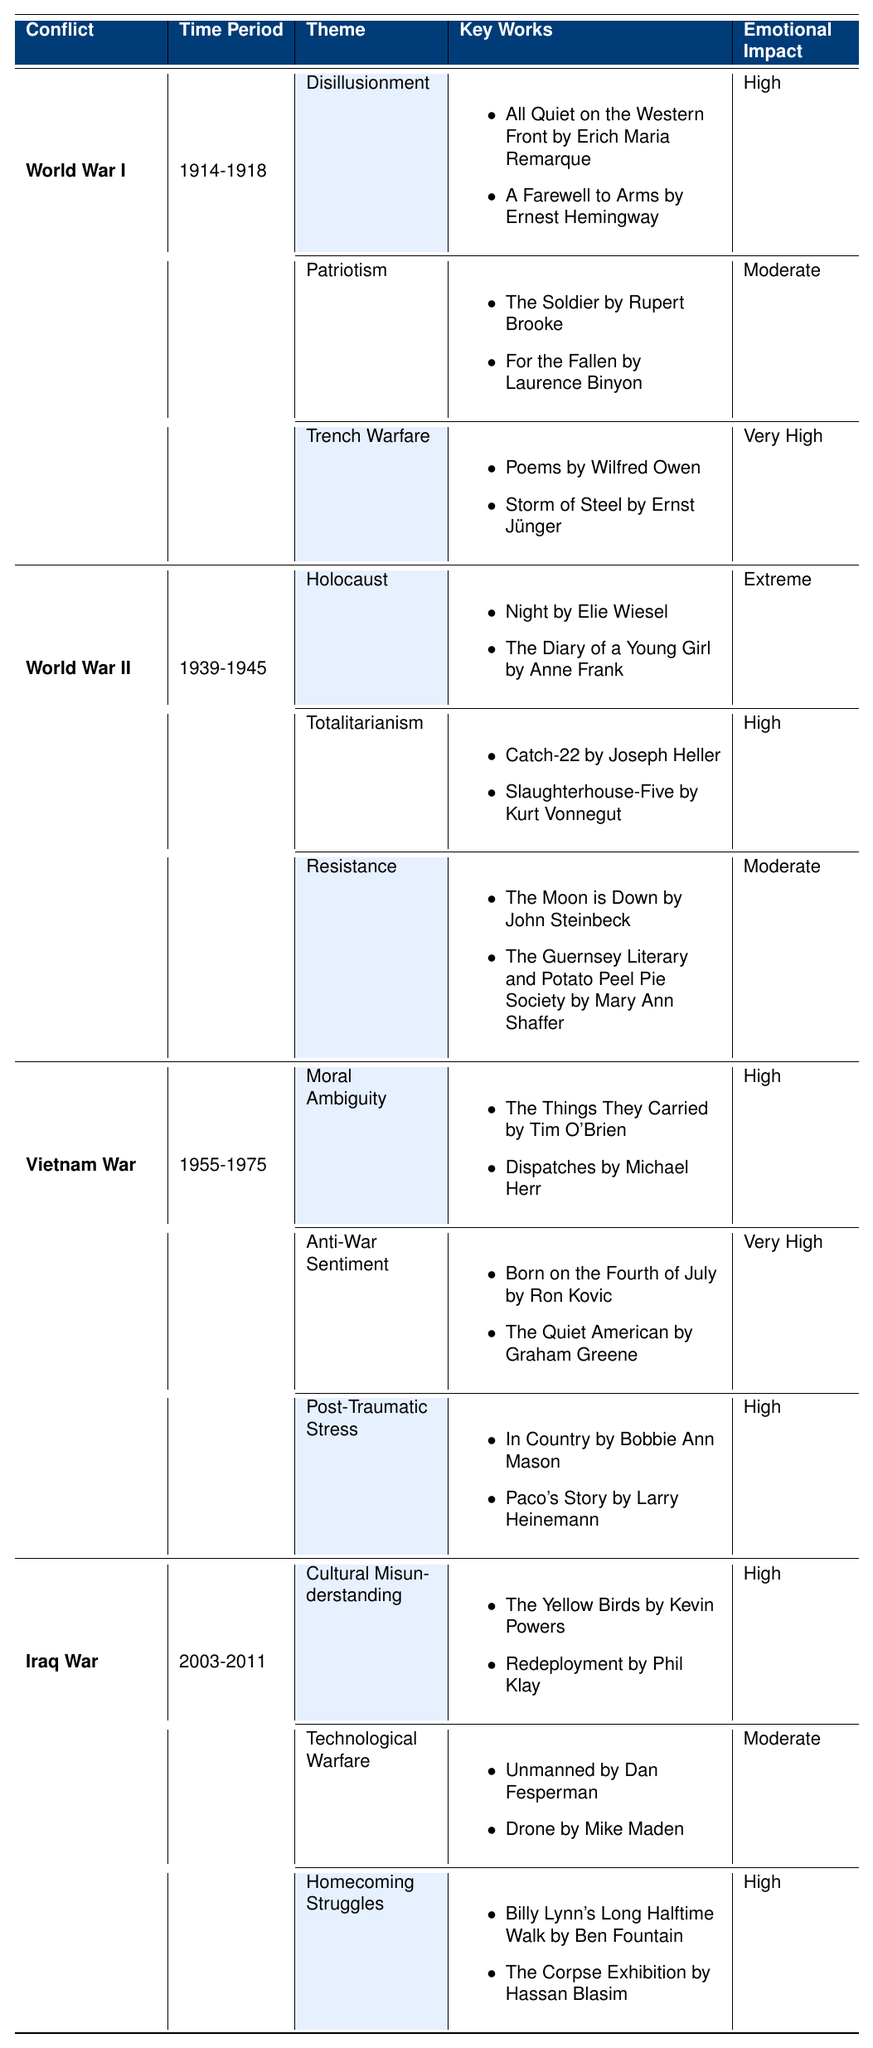What are the dominant themes of World War I? The table shows that the dominant themes of World War I are Disillusionment, Patriotism, and Trench Warfare.
Answer: Disillusionment, Patriotism, Trench Warfare Which conflict has the theme of Holocaust? Looking at the table, the theme of Holocaust is associated with World War II.
Answer: World War II How many key works are listed under the theme of Anti-War Sentiment in the Vietnam War? Under the theme of Anti-War Sentiment in the Vietnam War, two key works are listed: "Born on the Fourth of July" and "The Quiet American."
Answer: 2 What is the emotional impact of the theme of Cultural Misunderstanding in the Iraq War? The table indicates that the emotional impact of Cultural Misunderstanding in the Iraq War is High.
Answer: High Which conflict features the theme of Moral Ambiguity with a High emotional impact? The Vietnam War features the theme of Moral Ambiguity with a High emotional impact.
Answer: Vietnam War How many themes listed under World War II have an emotional impact categorized as Moderate? There is one theme under World War II that has an emotional impact categorized as Moderate, which is Resistance.
Answer: 1 Is there a theme among these conflicts that deals with post-traumatic stress? Yes, Post-Traumatic Stress is a theme associated with the Vietnam War.
Answer: Yes Which war literature theme from the Iraq War has a Moderate emotional impact? The theme from the Iraq War that has a Moderate emotional impact is Technological Warfare.
Answer: Technological Warfare Identify the conflict associated with the theme of Totalitarianism. The theme of Totalitarianism is associated with World War II.
Answer: World War II Count the themes with Very High emotional impact across all conflicts. In the table, there are three themes across different conflicts with a Very High emotional impact: Trench Warfare (World War I), Anti-War Sentiment (Vietnam War), and Trench Warfare again (as it appears as 'Very High'). Thus, the count is 3.
Answer: 3 